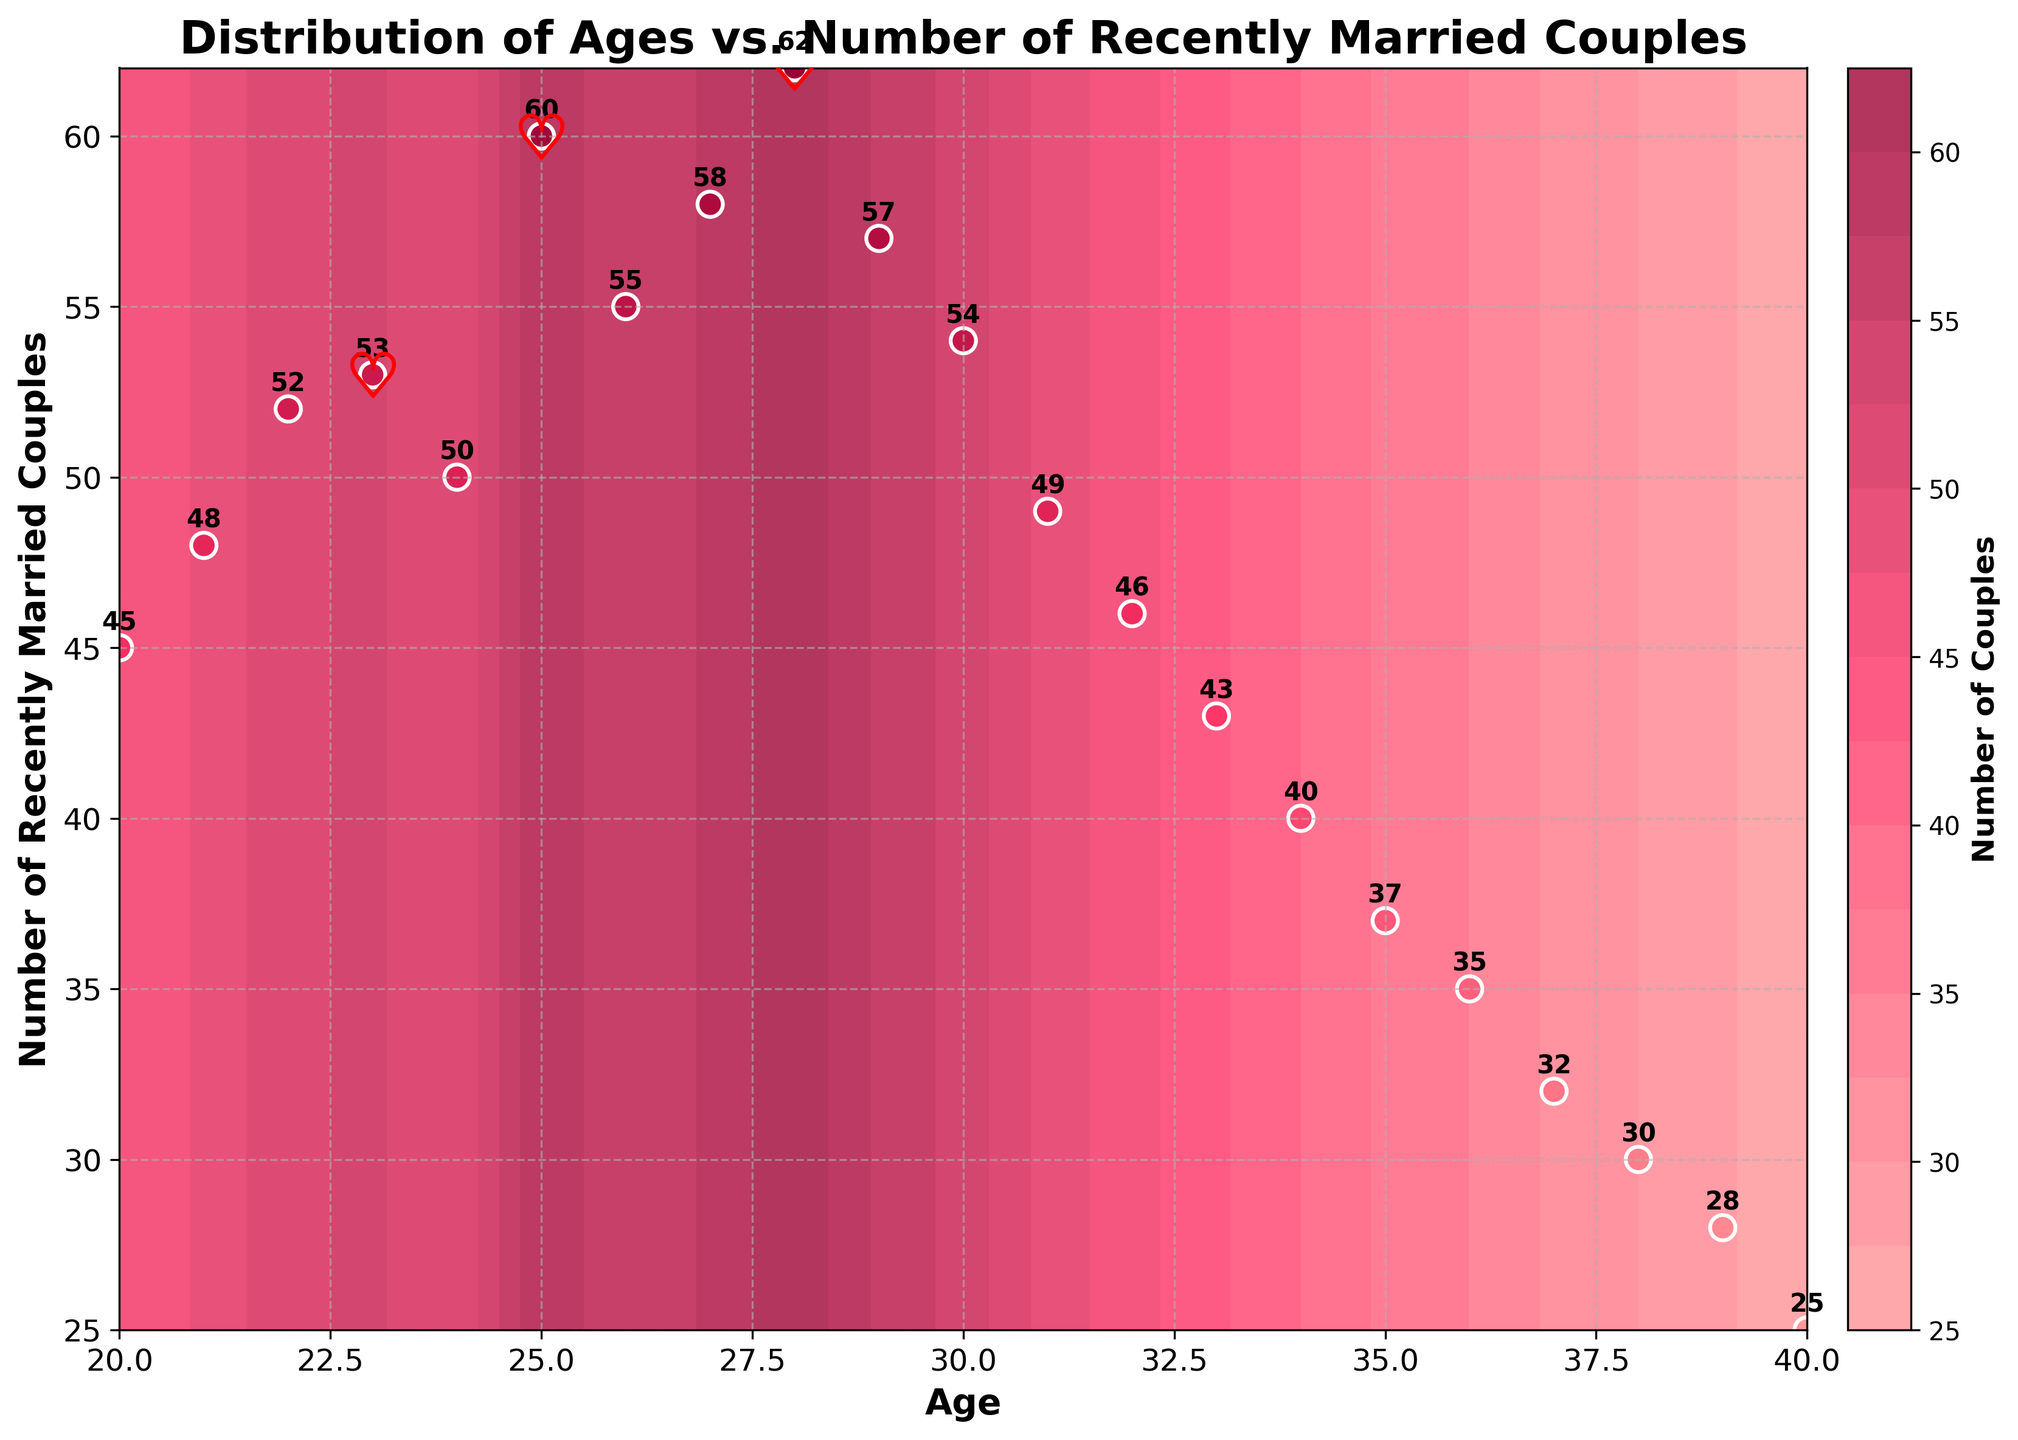What is the title of the plot? The title of the plot is typically found at the top of the figure, describing what the plot is about. In this case, the title mentions both the x and y axes.
Answer: Distribution of Ages vs. Number of Recently Married Couples Which age group has the highest number of recently married couples? Look at the scatter plot and identify the age corresponding to the highest y-value.
Answer: 28 How many data points are displayed in the scatter plot? Count the number of scatter points, which represent individual data points for ages and the number of recently married couples.
Answer: 21 At what ages do the heart markers indicating local maxima appear? The heart markers are used to highlight local maxima on the contour plot. Identify the ages where these markers are placed.
Answer: 23, 25, 27, 28 What is the range of the number of recently married couples shown on the y-axis? Check the minimum and maximum values labeled on the y-axis to determine the range of values.
Answer: 25 to 62 Between which two consecutive ages is the largest drop in the number of recently married couples? Compare the y-values of consecutive ages to find where the largest drop occurs by subtracting the number of couples at age i+1 from age i.
Answer: Between 28 and 29 What is the average number of recently married couples for ages under 30? Sum the y-values for ages 20 to 29 and divide by the number of data points in that range (10 points). Add the values: 45 + 48 + 52 + 53 + 50 + 60 + 55 + 58 + 62 + 57 = 540. Divide by 10 to get the average.
Answer: 54 Which age group has fewer than 30 recently married couples? Look at the scatter plot and identify the ages with y-values below 30.
Answer: 38, 39, 40 What is the color used for the heart markers? The heart markers have a distinct color different from the contour colors. Identify this color from the figure.
Answer: Red Is there any age group where the number of recently married couples is exactly 50? Check the scatter plot for any point where the y-value is exactly 50.
Answer: Yes, age 24 